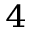<formula> <loc_0><loc_0><loc_500><loc_500>^ { 4 }</formula> 